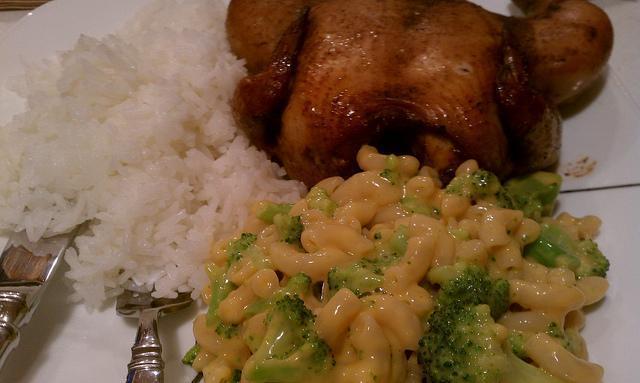How many broccolis are in the photo?
Give a very brief answer. 5. How many sinks are in this picture?
Give a very brief answer. 0. 